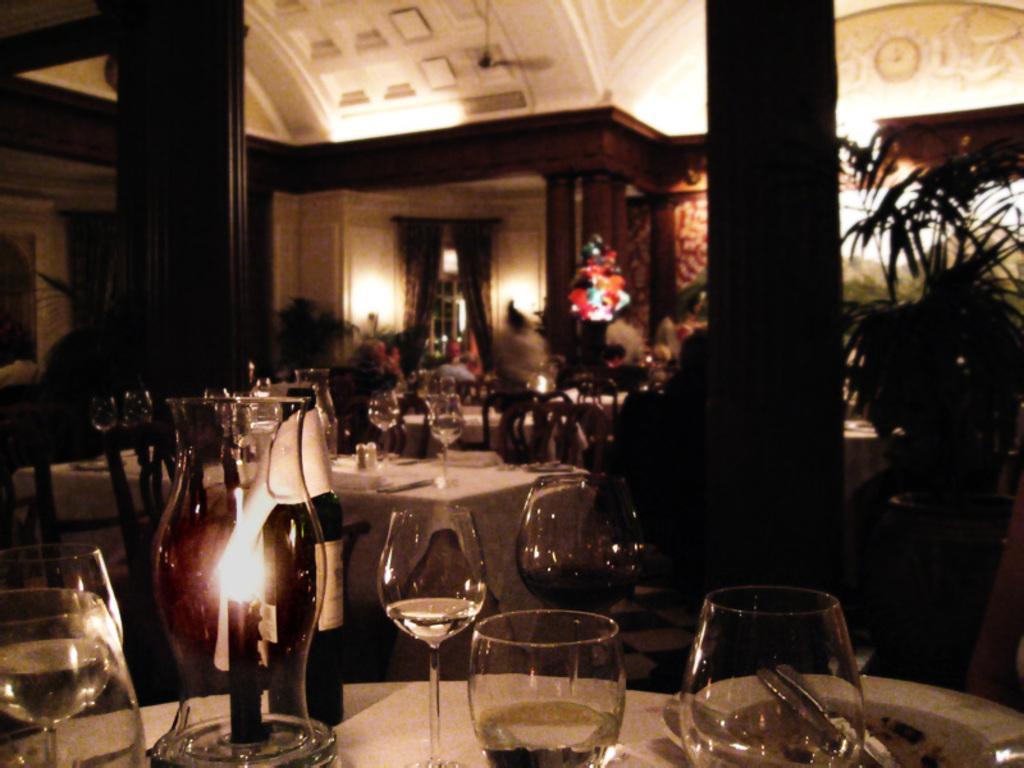What objects are on the table in the image? There are glasses and a candle on the table in the image. What architectural features can be seen in the image? There are two pillars visible in the image. What type of vegetation is present in the image? There is a plant in the image. Can you describe another table and its contents in the image? There is another table with items placed on it in the image. What type of wood is used to construct the nation in the image? There is no nation present in the image, and therefore no construction materials can be identified. 